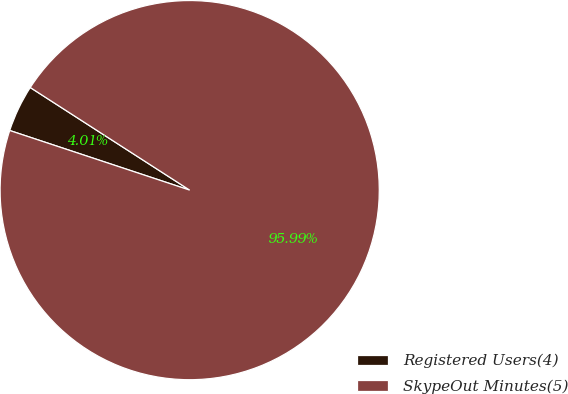<chart> <loc_0><loc_0><loc_500><loc_500><pie_chart><fcel>Registered Users(4)<fcel>SkypeOut Minutes(5)<nl><fcel>4.01%<fcel>95.99%<nl></chart> 